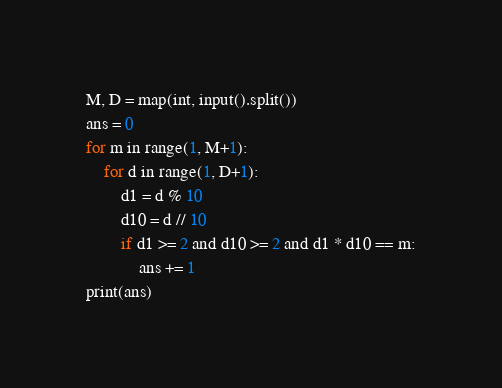Convert code to text. <code><loc_0><loc_0><loc_500><loc_500><_Python_>M, D = map(int, input().split())
ans = 0
for m in range(1, M+1):
    for d in range(1, D+1):
        d1 = d % 10
        d10 = d // 10
        if d1 >= 2 and d10 >= 2 and d1 * d10 == m:
            ans += 1
print(ans)
</code> 